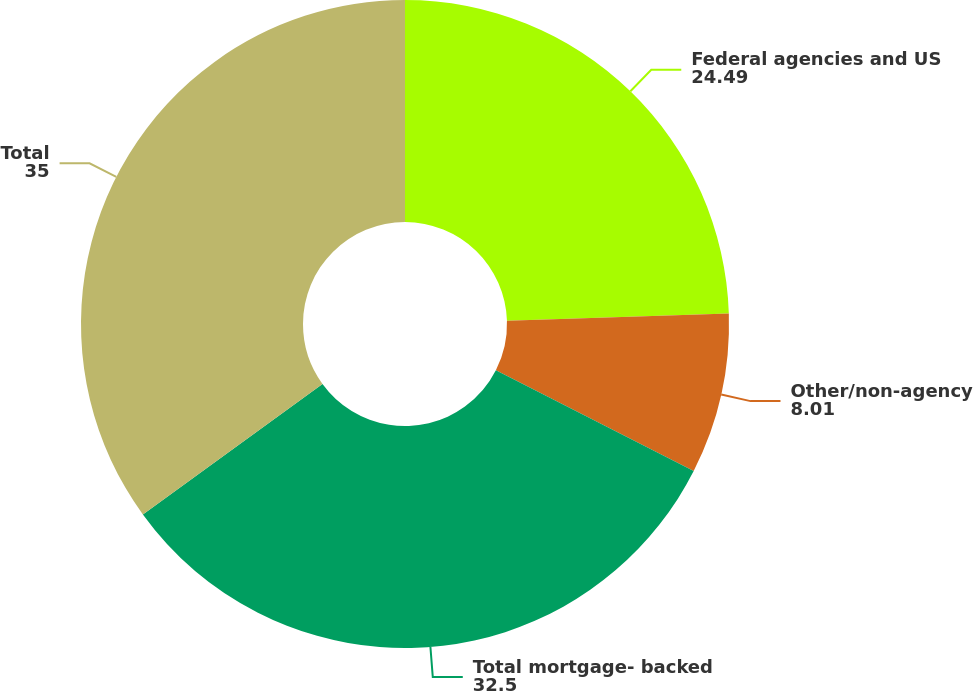Convert chart. <chart><loc_0><loc_0><loc_500><loc_500><pie_chart><fcel>Federal agencies and US<fcel>Other/non-agency<fcel>Total mortgage- backed<fcel>Total<nl><fcel>24.49%<fcel>8.01%<fcel>32.5%<fcel>35.0%<nl></chart> 